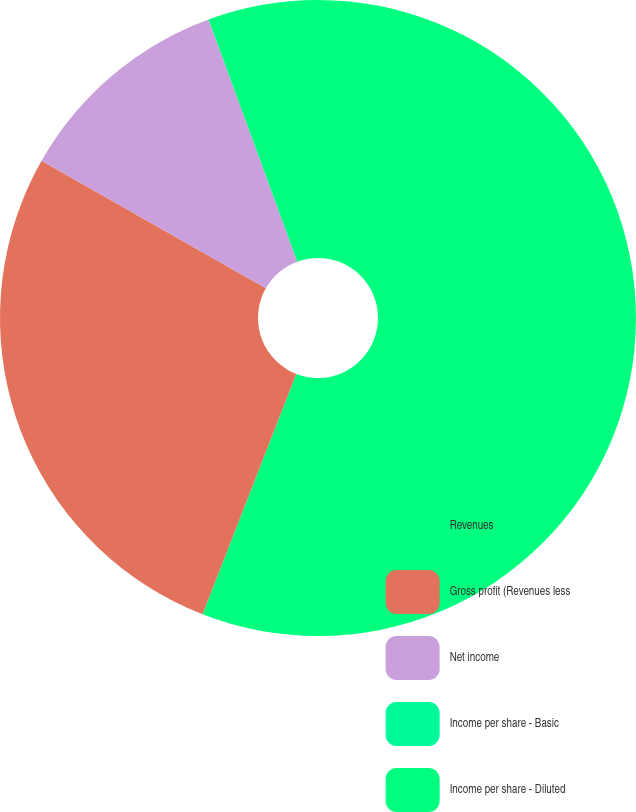Convert chart to OTSL. <chart><loc_0><loc_0><loc_500><loc_500><pie_chart><fcel>Revenues<fcel>Gross profit (Revenues less<fcel>Net income<fcel>Income per share - Basic<fcel>Income per share - Diluted<nl><fcel>55.91%<fcel>27.31%<fcel>11.18%<fcel>0.0%<fcel>5.59%<nl></chart> 